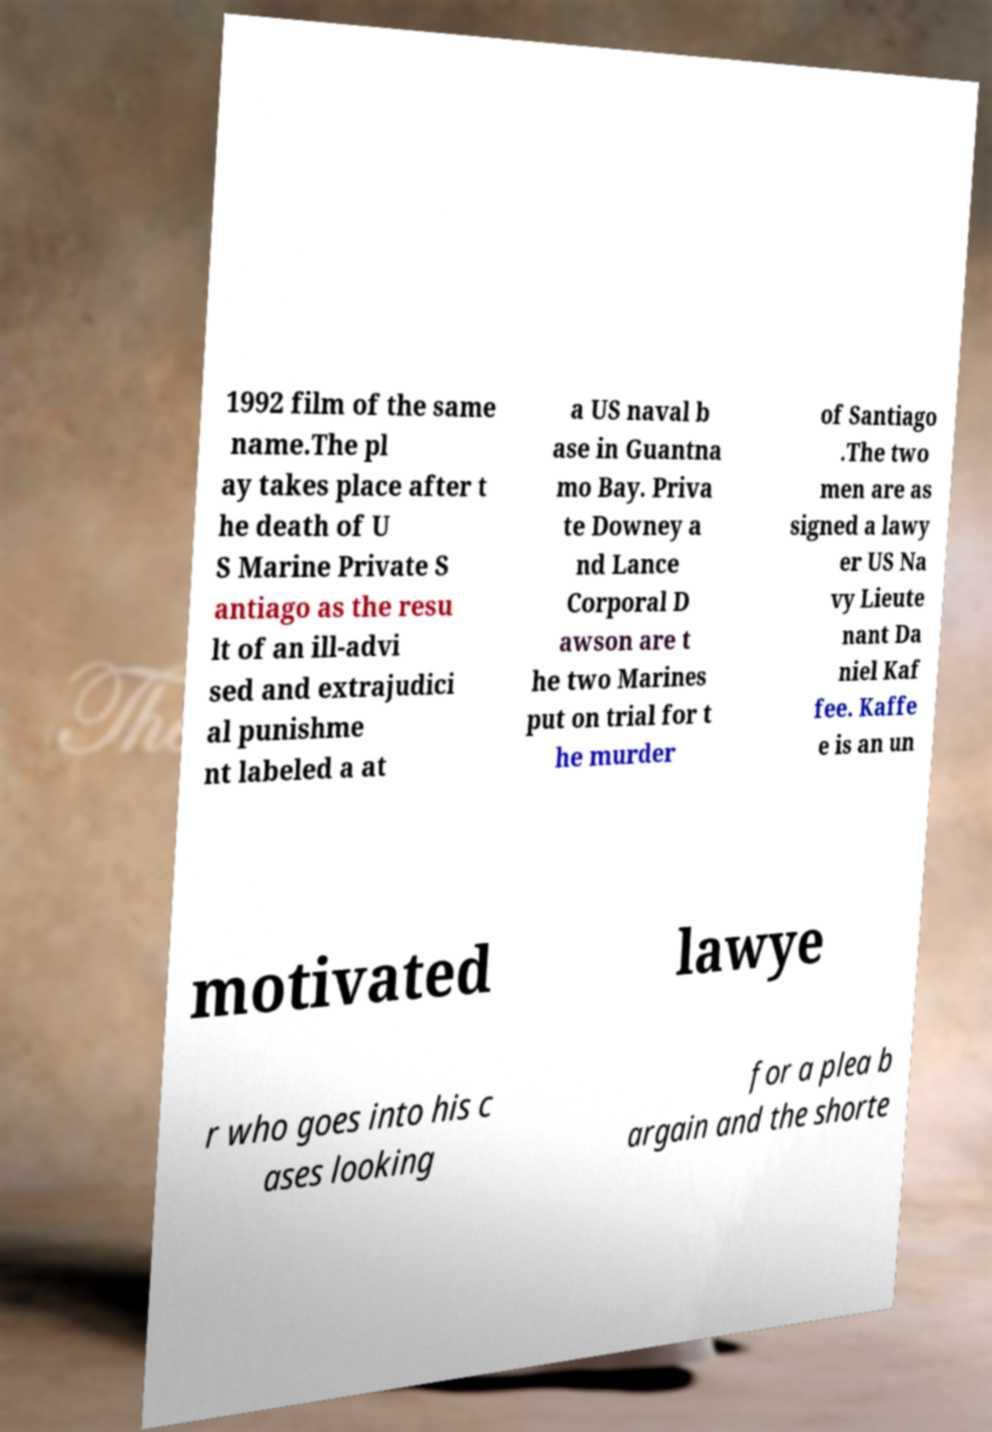Can you read and provide the text displayed in the image?This photo seems to have some interesting text. Can you extract and type it out for me? 1992 film of the same name.The pl ay takes place after t he death of U S Marine Private S antiago as the resu lt of an ill-advi sed and extrajudici al punishme nt labeled a at a US naval b ase in Guantna mo Bay. Priva te Downey a nd Lance Corporal D awson are t he two Marines put on trial for t he murder of Santiago .The two men are as signed a lawy er US Na vy Lieute nant Da niel Kaf fee. Kaffe e is an un motivated lawye r who goes into his c ases looking for a plea b argain and the shorte 